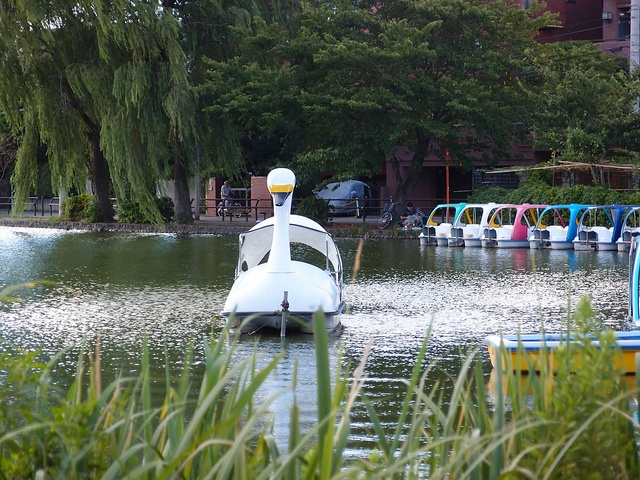Describe the objects in this image and their specific colors. I can see boat in darkgreen, lavender, gray, black, and lightgray tones, boat in darkgreen, olive, darkgray, and lavender tones, boat in darkgreen, black, lavender, gray, and blue tones, boat in darkgreen, lavender, black, gray, and darkgray tones, and boat in darkgreen, black, lavender, lightblue, and gray tones in this image. 